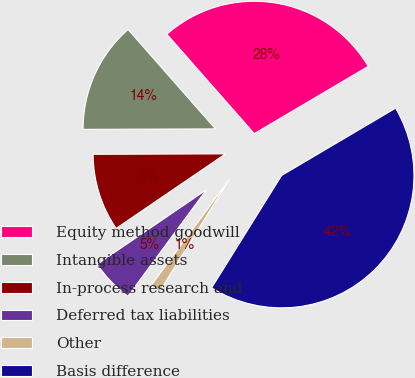Convert chart to OTSL. <chart><loc_0><loc_0><loc_500><loc_500><pie_chart><fcel>Equity method goodwill<fcel>Intangible assets<fcel>In-process research and<fcel>Deferred tax liabilities<fcel>Other<fcel>Basis difference<nl><fcel>27.98%<fcel>13.58%<fcel>9.47%<fcel>5.36%<fcel>1.25%<fcel>42.35%<nl></chart> 